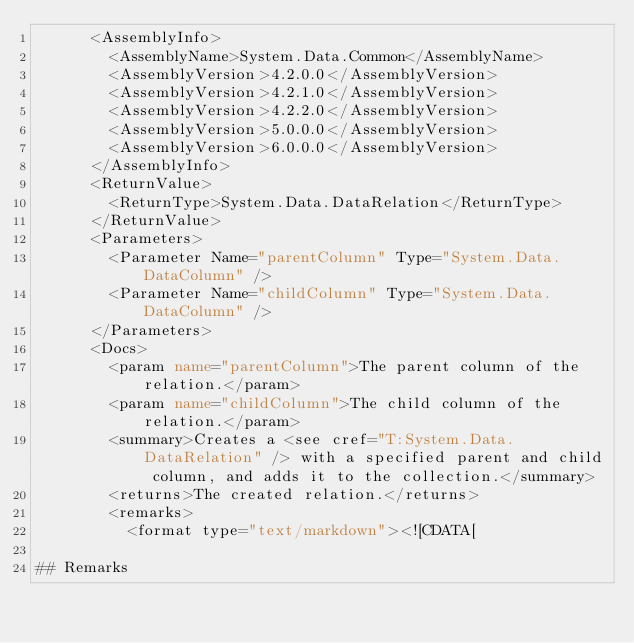<code> <loc_0><loc_0><loc_500><loc_500><_XML_>      <AssemblyInfo>
        <AssemblyName>System.Data.Common</AssemblyName>
        <AssemblyVersion>4.2.0.0</AssemblyVersion>
        <AssemblyVersion>4.2.1.0</AssemblyVersion>
        <AssemblyVersion>4.2.2.0</AssemblyVersion>
        <AssemblyVersion>5.0.0.0</AssemblyVersion>
        <AssemblyVersion>6.0.0.0</AssemblyVersion>
      </AssemblyInfo>
      <ReturnValue>
        <ReturnType>System.Data.DataRelation</ReturnType>
      </ReturnValue>
      <Parameters>
        <Parameter Name="parentColumn" Type="System.Data.DataColumn" />
        <Parameter Name="childColumn" Type="System.Data.DataColumn" />
      </Parameters>
      <Docs>
        <param name="parentColumn">The parent column of the relation.</param>
        <param name="childColumn">The child column of the relation.</param>
        <summary>Creates a <see cref="T:System.Data.DataRelation" /> with a specified parent and child column, and adds it to the collection.</summary>
        <returns>The created relation.</returns>
        <remarks>
          <format type="text/markdown"><![CDATA[  
  
## Remarks  </code> 